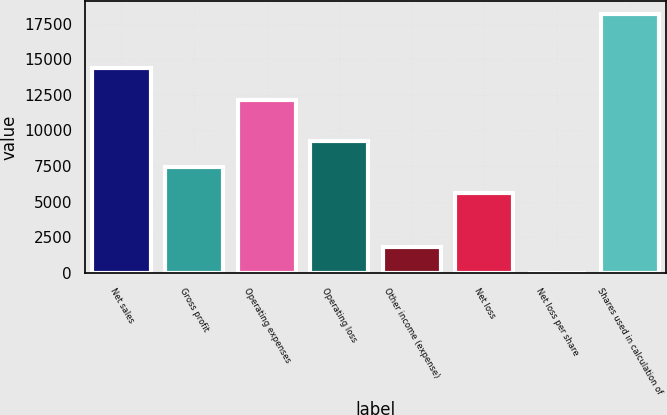Convert chart to OTSL. <chart><loc_0><loc_0><loc_500><loc_500><bar_chart><fcel>Net sales<fcel>Gross profit<fcel>Operating expenses<fcel>Operating loss<fcel>Other income (expense)<fcel>Net loss<fcel>Net loss per share<fcel>Shares used in calculation of<nl><fcel>14409<fcel>7432.37<fcel>12113<fcel>9247.74<fcel>1815.68<fcel>5617<fcel>0.31<fcel>18154<nl></chart> 